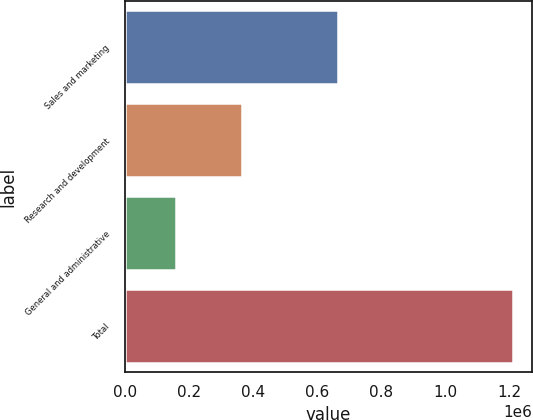<chart> <loc_0><loc_0><loc_500><loc_500><bar_chart><fcel>Sales and marketing<fcel>Research and development<fcel>General and administrative<fcel>Total<nl><fcel>664135<fcel>366084<fcel>160382<fcel>1.20903e+06<nl></chart> 